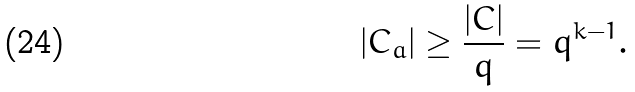Convert formula to latex. <formula><loc_0><loc_0><loc_500><loc_500>| C _ { a } | \geq \frac { | C | } { q } = q ^ { k - 1 } .</formula> 